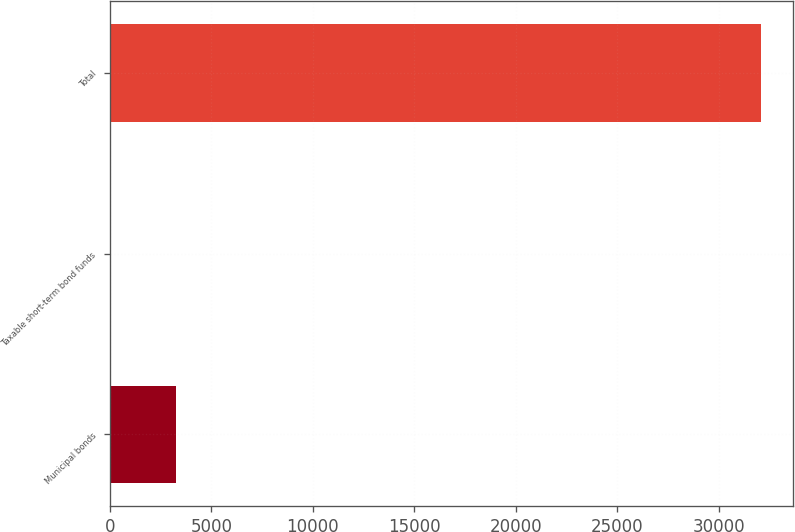Convert chart to OTSL. <chart><loc_0><loc_0><loc_500><loc_500><bar_chart><fcel>Municipal bonds<fcel>Taxable short-term bond funds<fcel>Total<nl><fcel>3276.5<fcel>76<fcel>32081<nl></chart> 